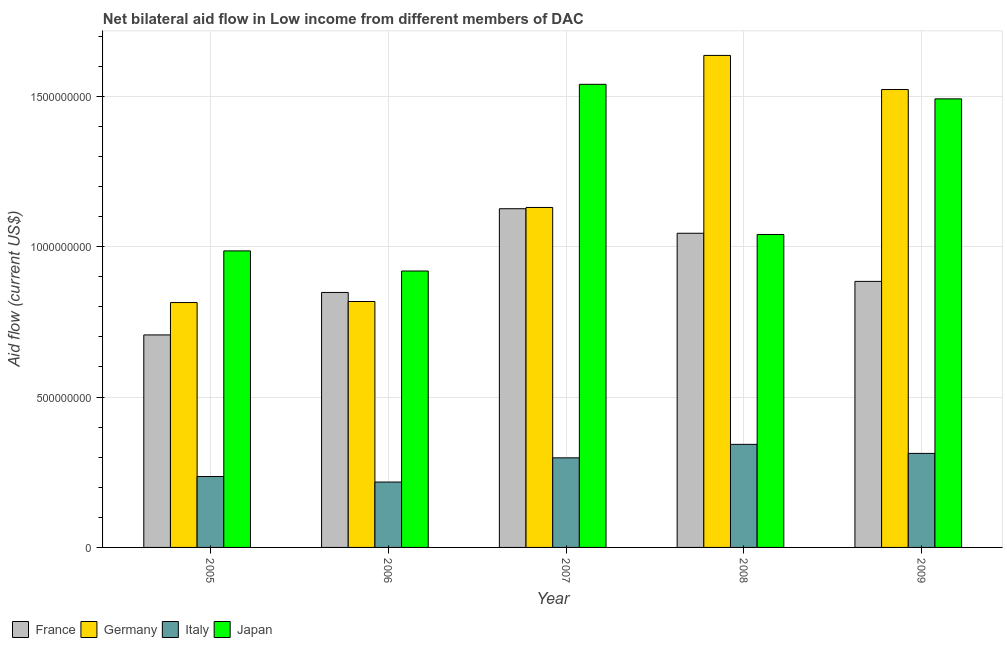How many groups of bars are there?
Your answer should be very brief. 5. Are the number of bars per tick equal to the number of legend labels?
Give a very brief answer. Yes. How many bars are there on the 3rd tick from the left?
Your response must be concise. 4. What is the label of the 1st group of bars from the left?
Keep it short and to the point. 2005. What is the amount of aid given by japan in 2008?
Provide a short and direct response. 1.04e+09. Across all years, what is the maximum amount of aid given by italy?
Give a very brief answer. 3.43e+08. Across all years, what is the minimum amount of aid given by germany?
Your answer should be very brief. 8.14e+08. In which year was the amount of aid given by france maximum?
Provide a short and direct response. 2007. What is the total amount of aid given by france in the graph?
Give a very brief answer. 4.61e+09. What is the difference between the amount of aid given by france in 2006 and that in 2007?
Keep it short and to the point. -2.78e+08. What is the difference between the amount of aid given by japan in 2005 and the amount of aid given by france in 2007?
Offer a terse response. -5.54e+08. What is the average amount of aid given by italy per year?
Make the answer very short. 2.81e+08. In how many years, is the amount of aid given by germany greater than 400000000 US$?
Keep it short and to the point. 5. What is the ratio of the amount of aid given by france in 2005 to that in 2007?
Your answer should be very brief. 0.63. Is the difference between the amount of aid given by france in 2005 and 2006 greater than the difference between the amount of aid given by japan in 2005 and 2006?
Provide a short and direct response. No. What is the difference between the highest and the second highest amount of aid given by france?
Offer a terse response. 8.16e+07. What is the difference between the highest and the lowest amount of aid given by japan?
Offer a very short reply. 6.21e+08. In how many years, is the amount of aid given by italy greater than the average amount of aid given by italy taken over all years?
Your answer should be very brief. 3. What does the 4th bar from the left in 2008 represents?
Keep it short and to the point. Japan. What does the 1st bar from the right in 2005 represents?
Give a very brief answer. Japan. Is it the case that in every year, the sum of the amount of aid given by france and amount of aid given by germany is greater than the amount of aid given by italy?
Ensure brevity in your answer.  Yes. Are the values on the major ticks of Y-axis written in scientific E-notation?
Offer a terse response. No. What is the title of the graph?
Provide a succinct answer. Net bilateral aid flow in Low income from different members of DAC. Does "Budget management" appear as one of the legend labels in the graph?
Your answer should be very brief. No. What is the label or title of the Y-axis?
Ensure brevity in your answer.  Aid flow (current US$). What is the Aid flow (current US$) of France in 2005?
Offer a very short reply. 7.07e+08. What is the Aid flow (current US$) of Germany in 2005?
Your response must be concise. 8.14e+08. What is the Aid flow (current US$) in Italy in 2005?
Offer a very short reply. 2.36e+08. What is the Aid flow (current US$) of Japan in 2005?
Provide a succinct answer. 9.86e+08. What is the Aid flow (current US$) of France in 2006?
Give a very brief answer. 8.48e+08. What is the Aid flow (current US$) of Germany in 2006?
Make the answer very short. 8.18e+08. What is the Aid flow (current US$) in Italy in 2006?
Ensure brevity in your answer.  2.17e+08. What is the Aid flow (current US$) in Japan in 2006?
Provide a succinct answer. 9.19e+08. What is the Aid flow (current US$) of France in 2007?
Ensure brevity in your answer.  1.13e+09. What is the Aid flow (current US$) in Germany in 2007?
Keep it short and to the point. 1.13e+09. What is the Aid flow (current US$) in Italy in 2007?
Offer a terse response. 2.98e+08. What is the Aid flow (current US$) in Japan in 2007?
Give a very brief answer. 1.54e+09. What is the Aid flow (current US$) in France in 2008?
Your answer should be very brief. 1.04e+09. What is the Aid flow (current US$) in Germany in 2008?
Provide a short and direct response. 1.64e+09. What is the Aid flow (current US$) of Italy in 2008?
Keep it short and to the point. 3.43e+08. What is the Aid flow (current US$) in Japan in 2008?
Offer a terse response. 1.04e+09. What is the Aid flow (current US$) of France in 2009?
Provide a short and direct response. 8.85e+08. What is the Aid flow (current US$) in Germany in 2009?
Your response must be concise. 1.52e+09. What is the Aid flow (current US$) in Italy in 2009?
Provide a short and direct response. 3.13e+08. What is the Aid flow (current US$) in Japan in 2009?
Offer a very short reply. 1.49e+09. Across all years, what is the maximum Aid flow (current US$) of France?
Provide a succinct answer. 1.13e+09. Across all years, what is the maximum Aid flow (current US$) of Germany?
Provide a succinct answer. 1.64e+09. Across all years, what is the maximum Aid flow (current US$) of Italy?
Your answer should be compact. 3.43e+08. Across all years, what is the maximum Aid flow (current US$) in Japan?
Ensure brevity in your answer.  1.54e+09. Across all years, what is the minimum Aid flow (current US$) in France?
Your response must be concise. 7.07e+08. Across all years, what is the minimum Aid flow (current US$) of Germany?
Your response must be concise. 8.14e+08. Across all years, what is the minimum Aid flow (current US$) in Italy?
Provide a short and direct response. 2.17e+08. Across all years, what is the minimum Aid flow (current US$) in Japan?
Offer a very short reply. 9.19e+08. What is the total Aid flow (current US$) of France in the graph?
Make the answer very short. 4.61e+09. What is the total Aid flow (current US$) in Germany in the graph?
Provide a succinct answer. 5.92e+09. What is the total Aid flow (current US$) in Italy in the graph?
Ensure brevity in your answer.  1.41e+09. What is the total Aid flow (current US$) of Japan in the graph?
Keep it short and to the point. 5.98e+09. What is the difference between the Aid flow (current US$) in France in 2005 and that in 2006?
Keep it short and to the point. -1.41e+08. What is the difference between the Aid flow (current US$) of Germany in 2005 and that in 2006?
Your answer should be very brief. -3.52e+06. What is the difference between the Aid flow (current US$) in Italy in 2005 and that in 2006?
Provide a short and direct response. 1.84e+07. What is the difference between the Aid flow (current US$) of Japan in 2005 and that in 2006?
Make the answer very short. 6.69e+07. What is the difference between the Aid flow (current US$) in France in 2005 and that in 2007?
Give a very brief answer. -4.20e+08. What is the difference between the Aid flow (current US$) in Germany in 2005 and that in 2007?
Your response must be concise. -3.16e+08. What is the difference between the Aid flow (current US$) in Italy in 2005 and that in 2007?
Keep it short and to the point. -6.21e+07. What is the difference between the Aid flow (current US$) of Japan in 2005 and that in 2007?
Your response must be concise. -5.54e+08. What is the difference between the Aid flow (current US$) in France in 2005 and that in 2008?
Provide a succinct answer. -3.38e+08. What is the difference between the Aid flow (current US$) in Germany in 2005 and that in 2008?
Your response must be concise. -8.22e+08. What is the difference between the Aid flow (current US$) of Italy in 2005 and that in 2008?
Give a very brief answer. -1.07e+08. What is the difference between the Aid flow (current US$) of Japan in 2005 and that in 2008?
Offer a terse response. -5.46e+07. What is the difference between the Aid flow (current US$) in France in 2005 and that in 2009?
Your answer should be compact. -1.78e+08. What is the difference between the Aid flow (current US$) in Germany in 2005 and that in 2009?
Ensure brevity in your answer.  -7.08e+08. What is the difference between the Aid flow (current US$) of Italy in 2005 and that in 2009?
Provide a succinct answer. -7.69e+07. What is the difference between the Aid flow (current US$) in Japan in 2005 and that in 2009?
Provide a short and direct response. -5.06e+08. What is the difference between the Aid flow (current US$) of France in 2006 and that in 2007?
Ensure brevity in your answer.  -2.78e+08. What is the difference between the Aid flow (current US$) in Germany in 2006 and that in 2007?
Keep it short and to the point. -3.13e+08. What is the difference between the Aid flow (current US$) of Italy in 2006 and that in 2007?
Offer a terse response. -8.05e+07. What is the difference between the Aid flow (current US$) in Japan in 2006 and that in 2007?
Your answer should be compact. -6.21e+08. What is the difference between the Aid flow (current US$) in France in 2006 and that in 2008?
Provide a short and direct response. -1.97e+08. What is the difference between the Aid flow (current US$) in Germany in 2006 and that in 2008?
Make the answer very short. -8.18e+08. What is the difference between the Aid flow (current US$) in Italy in 2006 and that in 2008?
Offer a very short reply. -1.25e+08. What is the difference between the Aid flow (current US$) of Japan in 2006 and that in 2008?
Give a very brief answer. -1.21e+08. What is the difference between the Aid flow (current US$) of France in 2006 and that in 2009?
Make the answer very short. -3.68e+07. What is the difference between the Aid flow (current US$) of Germany in 2006 and that in 2009?
Provide a short and direct response. -7.05e+08. What is the difference between the Aid flow (current US$) of Italy in 2006 and that in 2009?
Provide a short and direct response. -9.52e+07. What is the difference between the Aid flow (current US$) in Japan in 2006 and that in 2009?
Ensure brevity in your answer.  -5.72e+08. What is the difference between the Aid flow (current US$) in France in 2007 and that in 2008?
Keep it short and to the point. 8.16e+07. What is the difference between the Aid flow (current US$) in Germany in 2007 and that in 2008?
Ensure brevity in your answer.  -5.06e+08. What is the difference between the Aid flow (current US$) in Italy in 2007 and that in 2008?
Your response must be concise. -4.49e+07. What is the difference between the Aid flow (current US$) in Japan in 2007 and that in 2008?
Give a very brief answer. 4.99e+08. What is the difference between the Aid flow (current US$) of France in 2007 and that in 2009?
Provide a succinct answer. 2.42e+08. What is the difference between the Aid flow (current US$) in Germany in 2007 and that in 2009?
Keep it short and to the point. -3.92e+08. What is the difference between the Aid flow (current US$) of Italy in 2007 and that in 2009?
Provide a short and direct response. -1.48e+07. What is the difference between the Aid flow (current US$) in Japan in 2007 and that in 2009?
Keep it short and to the point. 4.84e+07. What is the difference between the Aid flow (current US$) in France in 2008 and that in 2009?
Ensure brevity in your answer.  1.60e+08. What is the difference between the Aid flow (current US$) in Germany in 2008 and that in 2009?
Your answer should be compact. 1.13e+08. What is the difference between the Aid flow (current US$) of Italy in 2008 and that in 2009?
Your answer should be very brief. 3.01e+07. What is the difference between the Aid flow (current US$) of Japan in 2008 and that in 2009?
Keep it short and to the point. -4.51e+08. What is the difference between the Aid flow (current US$) in France in 2005 and the Aid flow (current US$) in Germany in 2006?
Your response must be concise. -1.11e+08. What is the difference between the Aid flow (current US$) in France in 2005 and the Aid flow (current US$) in Italy in 2006?
Make the answer very short. 4.89e+08. What is the difference between the Aid flow (current US$) in France in 2005 and the Aid flow (current US$) in Japan in 2006?
Give a very brief answer. -2.13e+08. What is the difference between the Aid flow (current US$) in Germany in 2005 and the Aid flow (current US$) in Italy in 2006?
Give a very brief answer. 5.97e+08. What is the difference between the Aid flow (current US$) in Germany in 2005 and the Aid flow (current US$) in Japan in 2006?
Your response must be concise. -1.05e+08. What is the difference between the Aid flow (current US$) of Italy in 2005 and the Aid flow (current US$) of Japan in 2006?
Your answer should be very brief. -6.83e+08. What is the difference between the Aid flow (current US$) in France in 2005 and the Aid flow (current US$) in Germany in 2007?
Offer a very short reply. -4.24e+08. What is the difference between the Aid flow (current US$) of France in 2005 and the Aid flow (current US$) of Italy in 2007?
Provide a short and direct response. 4.09e+08. What is the difference between the Aid flow (current US$) of France in 2005 and the Aid flow (current US$) of Japan in 2007?
Provide a succinct answer. -8.33e+08. What is the difference between the Aid flow (current US$) in Germany in 2005 and the Aid flow (current US$) in Italy in 2007?
Ensure brevity in your answer.  5.16e+08. What is the difference between the Aid flow (current US$) in Germany in 2005 and the Aid flow (current US$) in Japan in 2007?
Your answer should be very brief. -7.26e+08. What is the difference between the Aid flow (current US$) in Italy in 2005 and the Aid flow (current US$) in Japan in 2007?
Your answer should be compact. -1.30e+09. What is the difference between the Aid flow (current US$) of France in 2005 and the Aid flow (current US$) of Germany in 2008?
Make the answer very short. -9.29e+08. What is the difference between the Aid flow (current US$) of France in 2005 and the Aid flow (current US$) of Italy in 2008?
Ensure brevity in your answer.  3.64e+08. What is the difference between the Aid flow (current US$) in France in 2005 and the Aid flow (current US$) in Japan in 2008?
Offer a terse response. -3.34e+08. What is the difference between the Aid flow (current US$) in Germany in 2005 and the Aid flow (current US$) in Italy in 2008?
Make the answer very short. 4.72e+08. What is the difference between the Aid flow (current US$) of Germany in 2005 and the Aid flow (current US$) of Japan in 2008?
Make the answer very short. -2.26e+08. What is the difference between the Aid flow (current US$) of Italy in 2005 and the Aid flow (current US$) of Japan in 2008?
Ensure brevity in your answer.  -8.05e+08. What is the difference between the Aid flow (current US$) in France in 2005 and the Aid flow (current US$) in Germany in 2009?
Offer a very short reply. -8.16e+08. What is the difference between the Aid flow (current US$) in France in 2005 and the Aid flow (current US$) in Italy in 2009?
Ensure brevity in your answer.  3.94e+08. What is the difference between the Aid flow (current US$) in France in 2005 and the Aid flow (current US$) in Japan in 2009?
Provide a short and direct response. -7.85e+08. What is the difference between the Aid flow (current US$) of Germany in 2005 and the Aid flow (current US$) of Italy in 2009?
Provide a succinct answer. 5.02e+08. What is the difference between the Aid flow (current US$) in Germany in 2005 and the Aid flow (current US$) in Japan in 2009?
Your response must be concise. -6.77e+08. What is the difference between the Aid flow (current US$) in Italy in 2005 and the Aid flow (current US$) in Japan in 2009?
Your answer should be very brief. -1.26e+09. What is the difference between the Aid flow (current US$) in France in 2006 and the Aid flow (current US$) in Germany in 2007?
Give a very brief answer. -2.83e+08. What is the difference between the Aid flow (current US$) of France in 2006 and the Aid flow (current US$) of Italy in 2007?
Ensure brevity in your answer.  5.50e+08. What is the difference between the Aid flow (current US$) of France in 2006 and the Aid flow (current US$) of Japan in 2007?
Your answer should be very brief. -6.92e+08. What is the difference between the Aid flow (current US$) in Germany in 2006 and the Aid flow (current US$) in Italy in 2007?
Ensure brevity in your answer.  5.20e+08. What is the difference between the Aid flow (current US$) of Germany in 2006 and the Aid flow (current US$) of Japan in 2007?
Offer a very short reply. -7.22e+08. What is the difference between the Aid flow (current US$) in Italy in 2006 and the Aid flow (current US$) in Japan in 2007?
Make the answer very short. -1.32e+09. What is the difference between the Aid flow (current US$) in France in 2006 and the Aid flow (current US$) in Germany in 2008?
Your response must be concise. -7.88e+08. What is the difference between the Aid flow (current US$) of France in 2006 and the Aid flow (current US$) of Italy in 2008?
Provide a succinct answer. 5.05e+08. What is the difference between the Aid flow (current US$) of France in 2006 and the Aid flow (current US$) of Japan in 2008?
Your answer should be very brief. -1.93e+08. What is the difference between the Aid flow (current US$) in Germany in 2006 and the Aid flow (current US$) in Italy in 2008?
Your response must be concise. 4.75e+08. What is the difference between the Aid flow (current US$) of Germany in 2006 and the Aid flow (current US$) of Japan in 2008?
Offer a terse response. -2.23e+08. What is the difference between the Aid flow (current US$) in Italy in 2006 and the Aid flow (current US$) in Japan in 2008?
Offer a terse response. -8.23e+08. What is the difference between the Aid flow (current US$) in France in 2006 and the Aid flow (current US$) in Germany in 2009?
Give a very brief answer. -6.75e+08. What is the difference between the Aid flow (current US$) in France in 2006 and the Aid flow (current US$) in Italy in 2009?
Keep it short and to the point. 5.35e+08. What is the difference between the Aid flow (current US$) in France in 2006 and the Aid flow (current US$) in Japan in 2009?
Keep it short and to the point. -6.44e+08. What is the difference between the Aid flow (current US$) of Germany in 2006 and the Aid flow (current US$) of Italy in 2009?
Keep it short and to the point. 5.05e+08. What is the difference between the Aid flow (current US$) in Germany in 2006 and the Aid flow (current US$) in Japan in 2009?
Your answer should be very brief. -6.74e+08. What is the difference between the Aid flow (current US$) of Italy in 2006 and the Aid flow (current US$) of Japan in 2009?
Offer a terse response. -1.27e+09. What is the difference between the Aid flow (current US$) of France in 2007 and the Aid flow (current US$) of Germany in 2008?
Offer a very short reply. -5.10e+08. What is the difference between the Aid flow (current US$) of France in 2007 and the Aid flow (current US$) of Italy in 2008?
Give a very brief answer. 7.84e+08. What is the difference between the Aid flow (current US$) in France in 2007 and the Aid flow (current US$) in Japan in 2008?
Make the answer very short. 8.57e+07. What is the difference between the Aid flow (current US$) of Germany in 2007 and the Aid flow (current US$) of Italy in 2008?
Provide a succinct answer. 7.88e+08. What is the difference between the Aid flow (current US$) in Germany in 2007 and the Aid flow (current US$) in Japan in 2008?
Keep it short and to the point. 8.99e+07. What is the difference between the Aid flow (current US$) of Italy in 2007 and the Aid flow (current US$) of Japan in 2008?
Offer a terse response. -7.43e+08. What is the difference between the Aid flow (current US$) of France in 2007 and the Aid flow (current US$) of Germany in 2009?
Give a very brief answer. -3.96e+08. What is the difference between the Aid flow (current US$) in France in 2007 and the Aid flow (current US$) in Italy in 2009?
Your response must be concise. 8.14e+08. What is the difference between the Aid flow (current US$) of France in 2007 and the Aid flow (current US$) of Japan in 2009?
Your response must be concise. -3.65e+08. What is the difference between the Aid flow (current US$) of Germany in 2007 and the Aid flow (current US$) of Italy in 2009?
Keep it short and to the point. 8.18e+08. What is the difference between the Aid flow (current US$) of Germany in 2007 and the Aid flow (current US$) of Japan in 2009?
Your response must be concise. -3.61e+08. What is the difference between the Aid flow (current US$) in Italy in 2007 and the Aid flow (current US$) in Japan in 2009?
Keep it short and to the point. -1.19e+09. What is the difference between the Aid flow (current US$) of France in 2008 and the Aid flow (current US$) of Germany in 2009?
Offer a very short reply. -4.78e+08. What is the difference between the Aid flow (current US$) in France in 2008 and the Aid flow (current US$) in Italy in 2009?
Your response must be concise. 7.32e+08. What is the difference between the Aid flow (current US$) of France in 2008 and the Aid flow (current US$) of Japan in 2009?
Your response must be concise. -4.47e+08. What is the difference between the Aid flow (current US$) of Germany in 2008 and the Aid flow (current US$) of Italy in 2009?
Your response must be concise. 1.32e+09. What is the difference between the Aid flow (current US$) in Germany in 2008 and the Aid flow (current US$) in Japan in 2009?
Provide a succinct answer. 1.44e+08. What is the difference between the Aid flow (current US$) in Italy in 2008 and the Aid flow (current US$) in Japan in 2009?
Provide a succinct answer. -1.15e+09. What is the average Aid flow (current US$) in France per year?
Keep it short and to the point. 9.22e+08. What is the average Aid flow (current US$) in Germany per year?
Offer a terse response. 1.18e+09. What is the average Aid flow (current US$) of Italy per year?
Offer a very short reply. 2.81e+08. What is the average Aid flow (current US$) of Japan per year?
Keep it short and to the point. 1.20e+09. In the year 2005, what is the difference between the Aid flow (current US$) in France and Aid flow (current US$) in Germany?
Make the answer very short. -1.08e+08. In the year 2005, what is the difference between the Aid flow (current US$) in France and Aid flow (current US$) in Italy?
Give a very brief answer. 4.71e+08. In the year 2005, what is the difference between the Aid flow (current US$) of France and Aid flow (current US$) of Japan?
Ensure brevity in your answer.  -2.79e+08. In the year 2005, what is the difference between the Aid flow (current US$) of Germany and Aid flow (current US$) of Italy?
Offer a terse response. 5.78e+08. In the year 2005, what is the difference between the Aid flow (current US$) in Germany and Aid flow (current US$) in Japan?
Provide a succinct answer. -1.72e+08. In the year 2005, what is the difference between the Aid flow (current US$) in Italy and Aid flow (current US$) in Japan?
Offer a very short reply. -7.50e+08. In the year 2006, what is the difference between the Aid flow (current US$) of France and Aid flow (current US$) of Germany?
Make the answer very short. 3.01e+07. In the year 2006, what is the difference between the Aid flow (current US$) of France and Aid flow (current US$) of Italy?
Provide a short and direct response. 6.30e+08. In the year 2006, what is the difference between the Aid flow (current US$) of France and Aid flow (current US$) of Japan?
Provide a short and direct response. -7.13e+07. In the year 2006, what is the difference between the Aid flow (current US$) of Germany and Aid flow (current US$) of Italy?
Your response must be concise. 6.00e+08. In the year 2006, what is the difference between the Aid flow (current US$) of Germany and Aid flow (current US$) of Japan?
Offer a very short reply. -1.01e+08. In the year 2006, what is the difference between the Aid flow (current US$) in Italy and Aid flow (current US$) in Japan?
Offer a very short reply. -7.02e+08. In the year 2007, what is the difference between the Aid flow (current US$) in France and Aid flow (current US$) in Germany?
Provide a succinct answer. -4.19e+06. In the year 2007, what is the difference between the Aid flow (current US$) of France and Aid flow (current US$) of Italy?
Make the answer very short. 8.28e+08. In the year 2007, what is the difference between the Aid flow (current US$) in France and Aid flow (current US$) in Japan?
Ensure brevity in your answer.  -4.14e+08. In the year 2007, what is the difference between the Aid flow (current US$) of Germany and Aid flow (current US$) of Italy?
Your answer should be compact. 8.33e+08. In the year 2007, what is the difference between the Aid flow (current US$) in Germany and Aid flow (current US$) in Japan?
Ensure brevity in your answer.  -4.09e+08. In the year 2007, what is the difference between the Aid flow (current US$) in Italy and Aid flow (current US$) in Japan?
Offer a very short reply. -1.24e+09. In the year 2008, what is the difference between the Aid flow (current US$) of France and Aid flow (current US$) of Germany?
Your answer should be very brief. -5.91e+08. In the year 2008, what is the difference between the Aid flow (current US$) in France and Aid flow (current US$) in Italy?
Offer a very short reply. 7.02e+08. In the year 2008, what is the difference between the Aid flow (current US$) of France and Aid flow (current US$) of Japan?
Make the answer very short. 4.11e+06. In the year 2008, what is the difference between the Aid flow (current US$) in Germany and Aid flow (current US$) in Italy?
Your response must be concise. 1.29e+09. In the year 2008, what is the difference between the Aid flow (current US$) of Germany and Aid flow (current US$) of Japan?
Your answer should be very brief. 5.95e+08. In the year 2008, what is the difference between the Aid flow (current US$) of Italy and Aid flow (current US$) of Japan?
Ensure brevity in your answer.  -6.98e+08. In the year 2009, what is the difference between the Aid flow (current US$) of France and Aid flow (current US$) of Germany?
Offer a terse response. -6.38e+08. In the year 2009, what is the difference between the Aid flow (current US$) of France and Aid flow (current US$) of Italy?
Keep it short and to the point. 5.72e+08. In the year 2009, what is the difference between the Aid flow (current US$) of France and Aid flow (current US$) of Japan?
Give a very brief answer. -6.07e+08. In the year 2009, what is the difference between the Aid flow (current US$) of Germany and Aid flow (current US$) of Italy?
Keep it short and to the point. 1.21e+09. In the year 2009, what is the difference between the Aid flow (current US$) of Germany and Aid flow (current US$) of Japan?
Provide a short and direct response. 3.10e+07. In the year 2009, what is the difference between the Aid flow (current US$) of Italy and Aid flow (current US$) of Japan?
Offer a very short reply. -1.18e+09. What is the ratio of the Aid flow (current US$) of France in 2005 to that in 2006?
Provide a short and direct response. 0.83. What is the ratio of the Aid flow (current US$) of Germany in 2005 to that in 2006?
Make the answer very short. 1. What is the ratio of the Aid flow (current US$) of Italy in 2005 to that in 2006?
Your answer should be compact. 1.08. What is the ratio of the Aid flow (current US$) in Japan in 2005 to that in 2006?
Provide a short and direct response. 1.07. What is the ratio of the Aid flow (current US$) of France in 2005 to that in 2007?
Your answer should be very brief. 0.63. What is the ratio of the Aid flow (current US$) of Germany in 2005 to that in 2007?
Your response must be concise. 0.72. What is the ratio of the Aid flow (current US$) in Italy in 2005 to that in 2007?
Offer a very short reply. 0.79. What is the ratio of the Aid flow (current US$) in Japan in 2005 to that in 2007?
Your answer should be very brief. 0.64. What is the ratio of the Aid flow (current US$) of France in 2005 to that in 2008?
Offer a very short reply. 0.68. What is the ratio of the Aid flow (current US$) of Germany in 2005 to that in 2008?
Offer a terse response. 0.5. What is the ratio of the Aid flow (current US$) in Italy in 2005 to that in 2008?
Make the answer very short. 0.69. What is the ratio of the Aid flow (current US$) in Japan in 2005 to that in 2008?
Keep it short and to the point. 0.95. What is the ratio of the Aid flow (current US$) in France in 2005 to that in 2009?
Provide a succinct answer. 0.8. What is the ratio of the Aid flow (current US$) in Germany in 2005 to that in 2009?
Make the answer very short. 0.53. What is the ratio of the Aid flow (current US$) in Italy in 2005 to that in 2009?
Offer a terse response. 0.75. What is the ratio of the Aid flow (current US$) of Japan in 2005 to that in 2009?
Your answer should be compact. 0.66. What is the ratio of the Aid flow (current US$) in France in 2006 to that in 2007?
Offer a terse response. 0.75. What is the ratio of the Aid flow (current US$) in Germany in 2006 to that in 2007?
Your answer should be very brief. 0.72. What is the ratio of the Aid flow (current US$) of Italy in 2006 to that in 2007?
Offer a terse response. 0.73. What is the ratio of the Aid flow (current US$) of Japan in 2006 to that in 2007?
Keep it short and to the point. 0.6. What is the ratio of the Aid flow (current US$) in France in 2006 to that in 2008?
Provide a short and direct response. 0.81. What is the ratio of the Aid flow (current US$) in Germany in 2006 to that in 2008?
Provide a succinct answer. 0.5. What is the ratio of the Aid flow (current US$) of Italy in 2006 to that in 2008?
Give a very brief answer. 0.63. What is the ratio of the Aid flow (current US$) of Japan in 2006 to that in 2008?
Offer a terse response. 0.88. What is the ratio of the Aid flow (current US$) of France in 2006 to that in 2009?
Your response must be concise. 0.96. What is the ratio of the Aid flow (current US$) in Germany in 2006 to that in 2009?
Your response must be concise. 0.54. What is the ratio of the Aid flow (current US$) in Italy in 2006 to that in 2009?
Give a very brief answer. 0.7. What is the ratio of the Aid flow (current US$) in Japan in 2006 to that in 2009?
Make the answer very short. 0.62. What is the ratio of the Aid flow (current US$) in France in 2007 to that in 2008?
Offer a terse response. 1.08. What is the ratio of the Aid flow (current US$) in Germany in 2007 to that in 2008?
Offer a terse response. 0.69. What is the ratio of the Aid flow (current US$) of Italy in 2007 to that in 2008?
Provide a short and direct response. 0.87. What is the ratio of the Aid flow (current US$) in Japan in 2007 to that in 2008?
Your response must be concise. 1.48. What is the ratio of the Aid flow (current US$) of France in 2007 to that in 2009?
Provide a short and direct response. 1.27. What is the ratio of the Aid flow (current US$) of Germany in 2007 to that in 2009?
Provide a succinct answer. 0.74. What is the ratio of the Aid flow (current US$) in Italy in 2007 to that in 2009?
Provide a short and direct response. 0.95. What is the ratio of the Aid flow (current US$) of Japan in 2007 to that in 2009?
Your response must be concise. 1.03. What is the ratio of the Aid flow (current US$) of France in 2008 to that in 2009?
Offer a very short reply. 1.18. What is the ratio of the Aid flow (current US$) of Germany in 2008 to that in 2009?
Keep it short and to the point. 1.07. What is the ratio of the Aid flow (current US$) of Italy in 2008 to that in 2009?
Your answer should be very brief. 1.1. What is the ratio of the Aid flow (current US$) of Japan in 2008 to that in 2009?
Your answer should be very brief. 0.7. What is the difference between the highest and the second highest Aid flow (current US$) of France?
Your answer should be compact. 8.16e+07. What is the difference between the highest and the second highest Aid flow (current US$) of Germany?
Provide a short and direct response. 1.13e+08. What is the difference between the highest and the second highest Aid flow (current US$) of Italy?
Give a very brief answer. 3.01e+07. What is the difference between the highest and the second highest Aid flow (current US$) of Japan?
Your response must be concise. 4.84e+07. What is the difference between the highest and the lowest Aid flow (current US$) in France?
Make the answer very short. 4.20e+08. What is the difference between the highest and the lowest Aid flow (current US$) of Germany?
Offer a very short reply. 8.22e+08. What is the difference between the highest and the lowest Aid flow (current US$) of Italy?
Your answer should be very brief. 1.25e+08. What is the difference between the highest and the lowest Aid flow (current US$) in Japan?
Offer a terse response. 6.21e+08. 